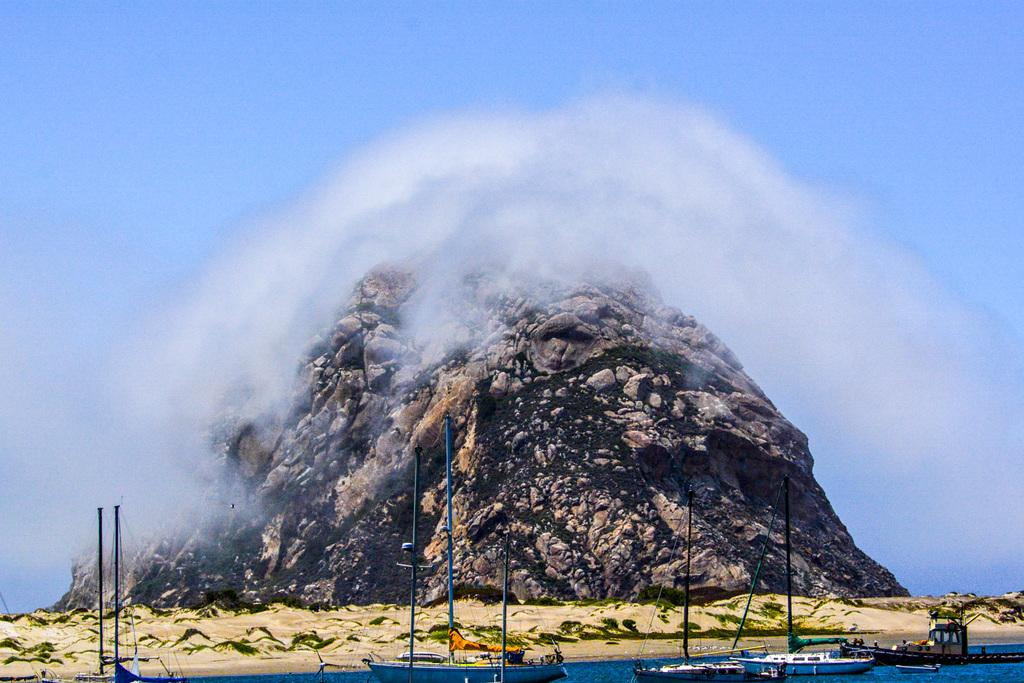What type of vehicles are in the image? There are boats in the image. Where are the boats located? The boats are on the water. What can be seen in the background of the image? There is a rocky mountain in the background of the image. What is visible in the sky in the image? There are clouds in the sky, and the sky is visible in the background of the image. What type of base is supporting the sun in the image? There is no base present in the image, and the sun is not visible. The image features boats on the water with a rocky mountain in the background and clouds in the sky. 